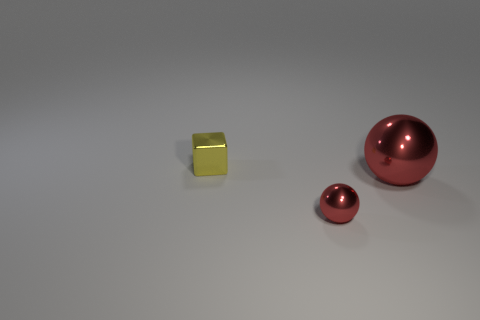How many objects are objects that are in front of the small yellow metallic object or small red objects?
Make the answer very short. 2. What number of yellow objects are large spheres or small metal balls?
Offer a terse response. 0. What number of other objects are the same color as the metallic cube?
Keep it short and to the point. 0. Are there fewer small yellow objects to the left of the small yellow metallic object than tiny red shiny objects?
Offer a terse response. Yes. What is the color of the tiny object that is in front of the shiny object that is behind the shiny sphere that is behind the small red thing?
Offer a very short reply. Red. The other metallic thing that is the same shape as the big red thing is what size?
Provide a short and direct response. Small. Are there fewer red metallic objects behind the large ball than red metallic objects that are behind the yellow metal block?
Give a very brief answer. No. What shape is the thing that is both on the left side of the big metallic sphere and on the right side of the tiny yellow cube?
Keep it short and to the point. Sphere. What size is the other ball that is the same material as the small ball?
Your answer should be compact. Large. There is a big object; is it the same color as the tiny thing that is in front of the cube?
Your answer should be very brief. Yes. 